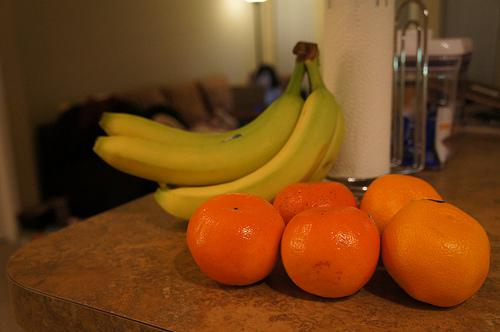Question: what color are the bananas?
Choices:
A. White.
B. Brown.
C. Black.
D. Yellow.
Answer with the letter. Answer: D Question: what yellow food is pictured?
Choices:
A. Lemons.
B. Yellow curry.
C. Macaroni and Cheese.
D. Bananas.
Answer with the letter. Answer: D Question: what orange food is pictured?
Choices:
A. Carrots.
B. Pumpkin.
C. Oranges.
D. Bell pepper.
Answer with the letter. Answer: C Question: what room does this appear to be in?
Choices:
A. Bathroom.
B. Kitchen.
C. Bedroom.
D. Living room.
Answer with the letter. Answer: B Question: how many oranges are there?
Choices:
A. 4.
B. 3.
C. 5.
D. 2.
Answer with the letter. Answer: C 